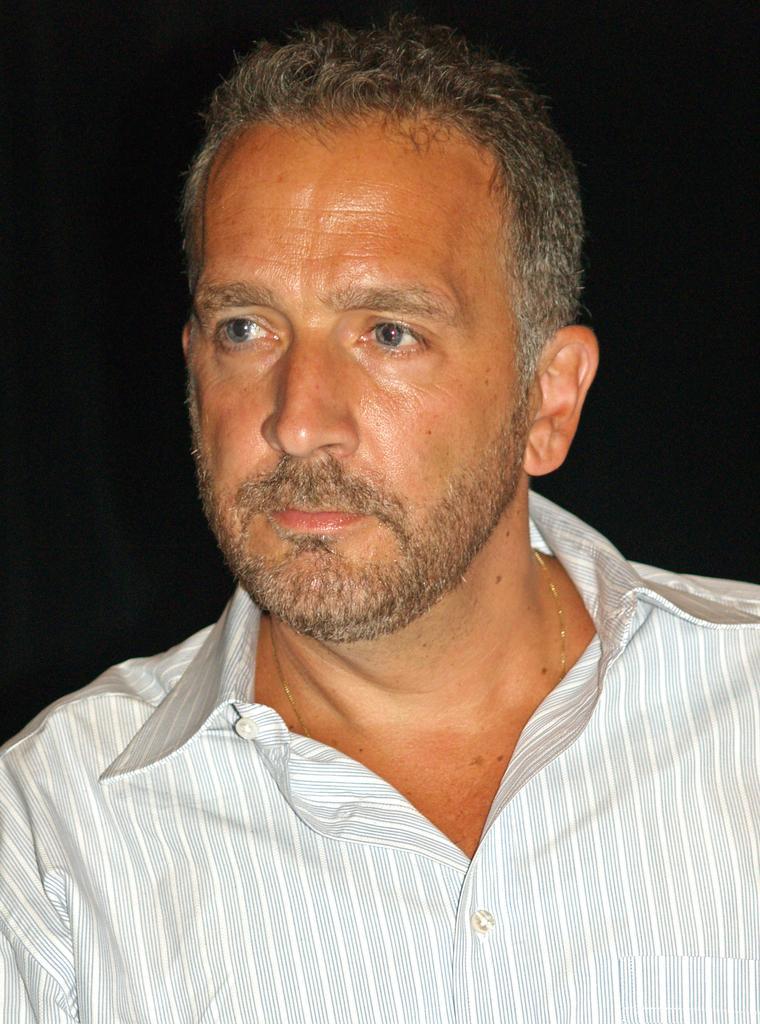Describe this image in one or two sentences. In this picture there is a man wearing a white shirt is looking on the left side. Behind there is a black background. 